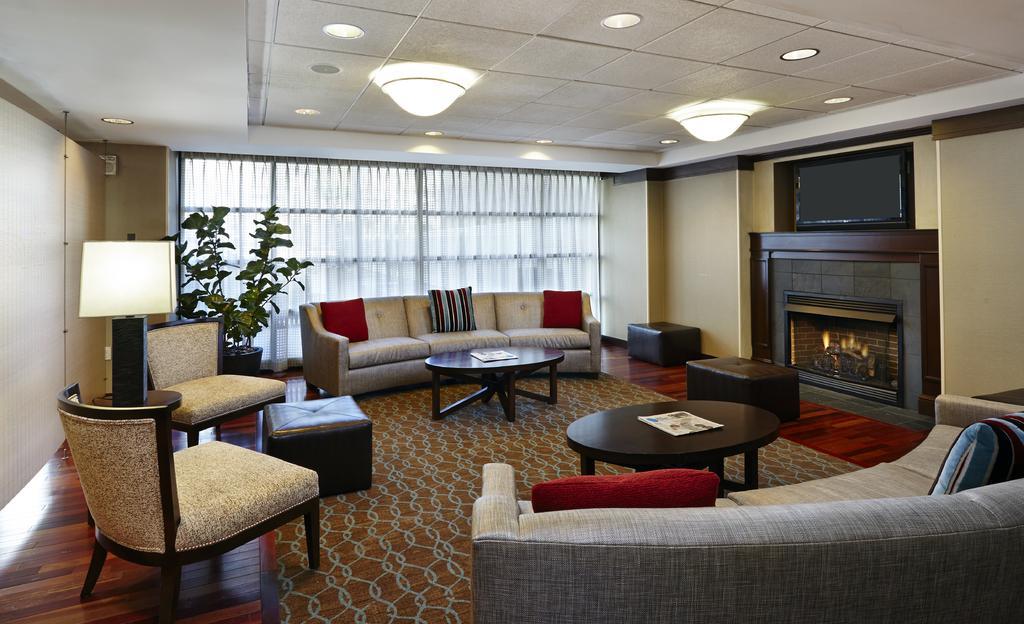Can you describe this image briefly? This picture shows a plant and sofa with pillows and we see two chairs and couple of tables and three stools and a fireplace and few lights and curtains to the window and we see a book stand on the side 